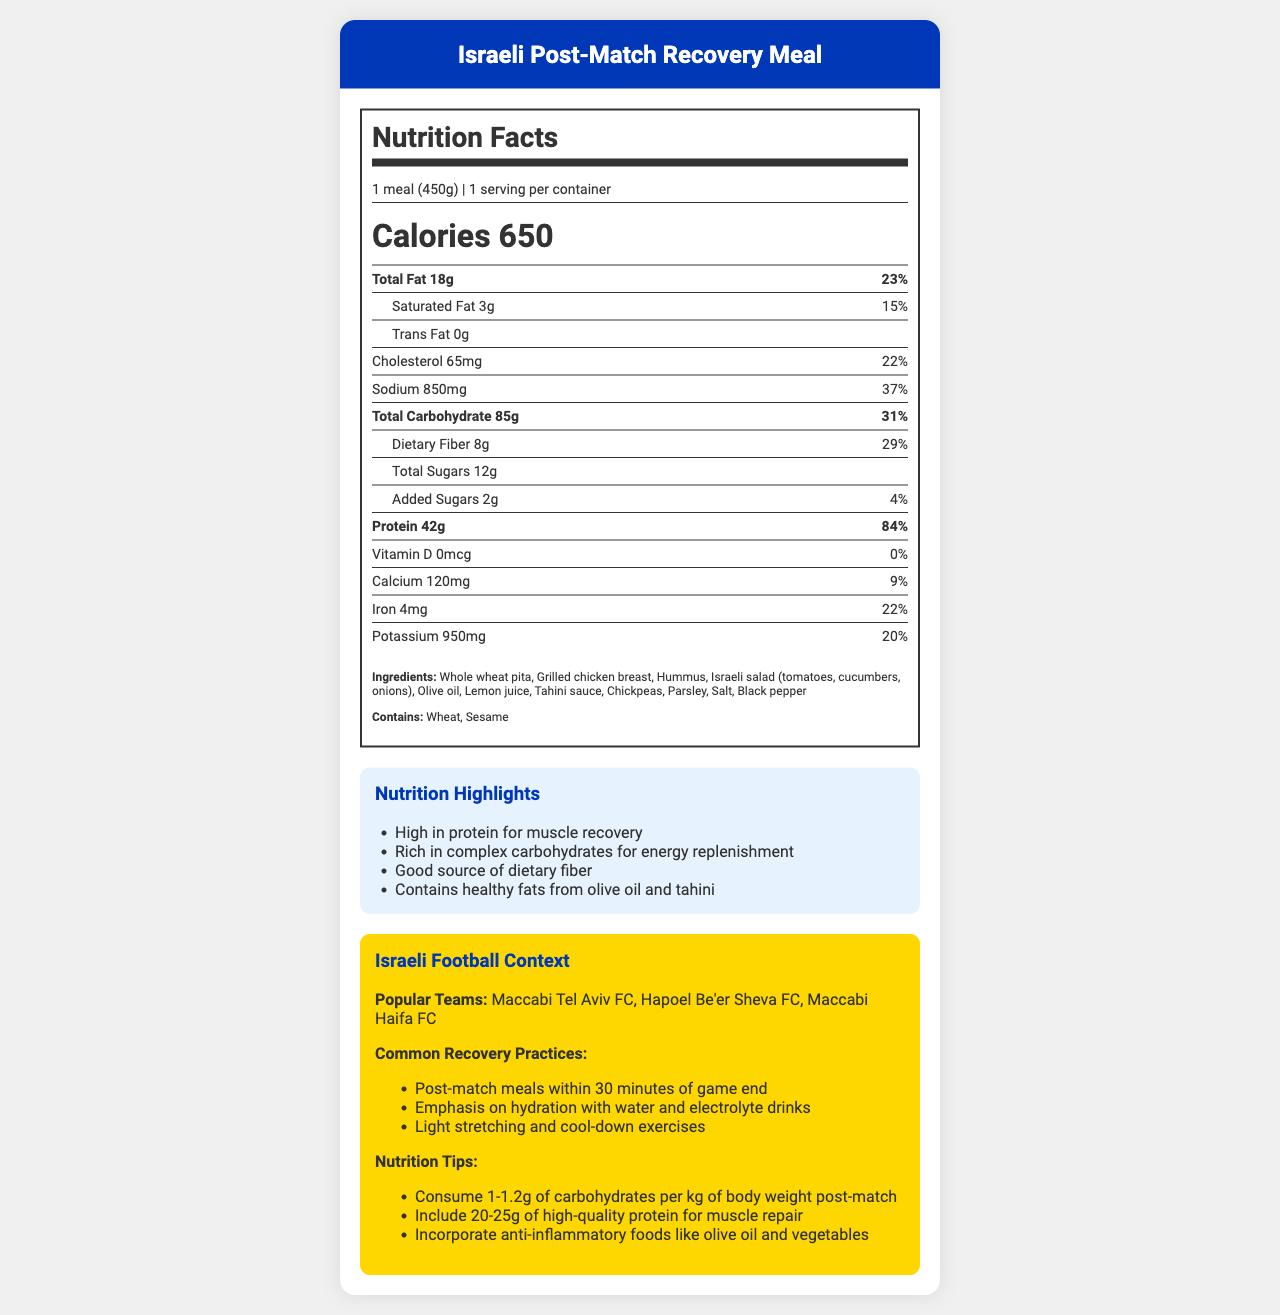what is the serving size of the Israeli Post-Match Recovery Meal? The document explicitly states that the serving size is "1 meal (450g)".
Answer: 1 meal (450g) How much protein does one serving of this meal provide? The document specifies that one serving provides 42g of protein.
Answer: 42g What is the percentage daily value of total carbohydrates in one serving? According to the document, the daily value percentage for total carbohydrates is 31%.
Answer: 31% Name two allergens present in this meal. The document lists "Wheat" and "Sesame" under the allergens section.
Answer: Wheat, Sesame List three ingredients in this meal. The ingredients section of the document includes these components.
Answer: Whole wheat pita, Grilled chicken breast, Hummus Which of the following nutrients is NOT listed in the nutrition facts? A. Vitamin C B. Vitamin D C. Calcium D. Potassium The document provides amounts for Vitamin D, Calcium, and Potassium, but Vitamin C is not listed.
Answer: A. Vitamin C How much dietary fiber is contained in one serving of the meal? The document notes that there are 8g of dietary fiber in one serving.
Answer: 8g Which teams are mentioned as popular in the context of Israeli football? A. Maccabi Tel Aviv FC B. Hapoel Be'er Sheva FC C. Maccabi Haifa FC D. All of the above The document mentions all three teams under "Popular Teams": Maccabi Tel Aviv FC, Hapoel Be'er Sheva FC, and Maccabi Haifa FC.
Answer: D. All of the above Is this meal high in protein? The document highlights that the meal is high in protein, with 42g per serving and an 84% daily value.
Answer: Yes Summarize the main points of the document. The document includes comprehensive nutritional details, highlights its benefits for post-match recovery, and provides context on its relevance in Israeli football culture.
Answer: The document describes the nutrition facts of an Israeli Post-Match Recovery Meal, including its serving size, calories, macro and micronutrient content, ingredients, allergens, and its role in Israeli football recovery practices. The meal is emphasized as high in protein and carbohydrates, suitable for muscle recovery and energy replenishment. Is this meal low in sodium? The sodium content is listed as 850mg, which is 37% of the daily value, indicating a relatively high level of sodium.
Answer: No What is the total amount of sugar in one serving? The document indicates that the total amount of sugar in one serving is 12g.
Answer: 12g What does the document suggest about the timing of post-match meals? According to the context provided in Israeli football, it suggests consuming post-match meals within 30 minutes of the game ending.
Answer: Within 30 minutes of game end How much iron is in one serving? The document details that there are 4mg of iron per serving.
Answer: 4mg Can you determine the brand of this meal from the document? The document does not provide any branding or manufacturer information.
Answer: Cannot be determined 